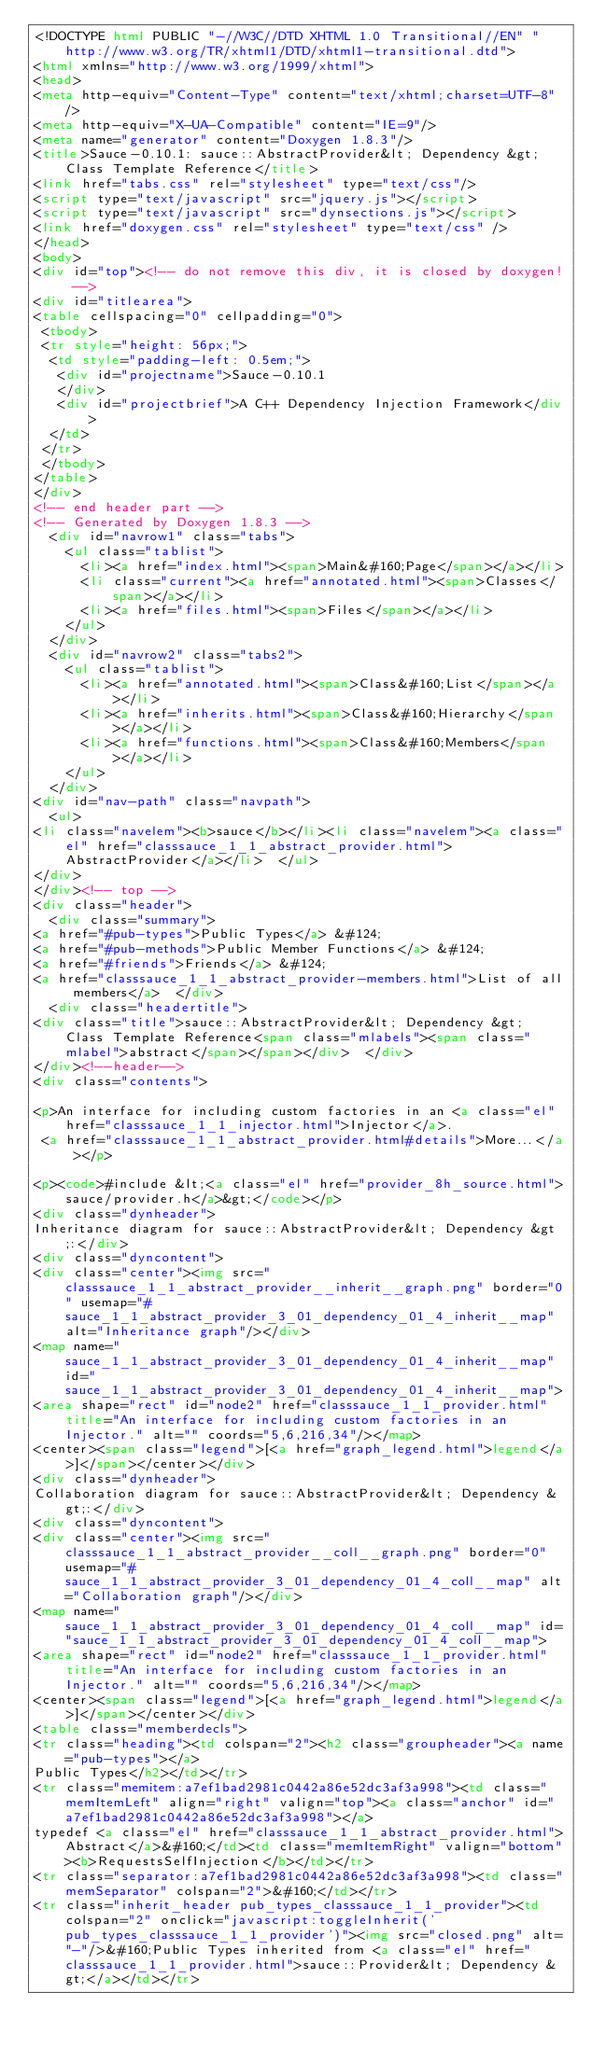Convert code to text. <code><loc_0><loc_0><loc_500><loc_500><_HTML_><!DOCTYPE html PUBLIC "-//W3C//DTD XHTML 1.0 Transitional//EN" "http://www.w3.org/TR/xhtml1/DTD/xhtml1-transitional.dtd">
<html xmlns="http://www.w3.org/1999/xhtml">
<head>
<meta http-equiv="Content-Type" content="text/xhtml;charset=UTF-8"/>
<meta http-equiv="X-UA-Compatible" content="IE=9"/>
<meta name="generator" content="Doxygen 1.8.3"/>
<title>Sauce-0.10.1: sauce::AbstractProvider&lt; Dependency &gt; Class Template Reference</title>
<link href="tabs.css" rel="stylesheet" type="text/css"/>
<script type="text/javascript" src="jquery.js"></script>
<script type="text/javascript" src="dynsections.js"></script>
<link href="doxygen.css" rel="stylesheet" type="text/css" />
</head>
<body>
<div id="top"><!-- do not remove this div, it is closed by doxygen! -->
<div id="titlearea">
<table cellspacing="0" cellpadding="0">
 <tbody>
 <tr style="height: 56px;">
  <td style="padding-left: 0.5em;">
   <div id="projectname">Sauce-0.10.1
   </div>
   <div id="projectbrief">A C++ Dependency Injection Framework</div>
  </td>
 </tr>
 </tbody>
</table>
</div>
<!-- end header part -->
<!-- Generated by Doxygen 1.8.3 -->
  <div id="navrow1" class="tabs">
    <ul class="tablist">
      <li><a href="index.html"><span>Main&#160;Page</span></a></li>
      <li class="current"><a href="annotated.html"><span>Classes</span></a></li>
      <li><a href="files.html"><span>Files</span></a></li>
    </ul>
  </div>
  <div id="navrow2" class="tabs2">
    <ul class="tablist">
      <li><a href="annotated.html"><span>Class&#160;List</span></a></li>
      <li><a href="inherits.html"><span>Class&#160;Hierarchy</span></a></li>
      <li><a href="functions.html"><span>Class&#160;Members</span></a></li>
    </ul>
  </div>
<div id="nav-path" class="navpath">
  <ul>
<li class="navelem"><b>sauce</b></li><li class="navelem"><a class="el" href="classsauce_1_1_abstract_provider.html">AbstractProvider</a></li>  </ul>
</div>
</div><!-- top -->
<div class="header">
  <div class="summary">
<a href="#pub-types">Public Types</a> &#124;
<a href="#pub-methods">Public Member Functions</a> &#124;
<a href="#friends">Friends</a> &#124;
<a href="classsauce_1_1_abstract_provider-members.html">List of all members</a>  </div>
  <div class="headertitle">
<div class="title">sauce::AbstractProvider&lt; Dependency &gt; Class Template Reference<span class="mlabels"><span class="mlabel">abstract</span></span></div>  </div>
</div><!--header-->
<div class="contents">

<p>An interface for including custom factories in an <a class="el" href="classsauce_1_1_injector.html">Injector</a>.  
 <a href="classsauce_1_1_abstract_provider.html#details">More...</a></p>

<p><code>#include &lt;<a class="el" href="provider_8h_source.html">sauce/provider.h</a>&gt;</code></p>
<div class="dynheader">
Inheritance diagram for sauce::AbstractProvider&lt; Dependency &gt;:</div>
<div class="dyncontent">
<div class="center"><img src="classsauce_1_1_abstract_provider__inherit__graph.png" border="0" usemap="#sauce_1_1_abstract_provider_3_01_dependency_01_4_inherit__map" alt="Inheritance graph"/></div>
<map name="sauce_1_1_abstract_provider_3_01_dependency_01_4_inherit__map" id="sauce_1_1_abstract_provider_3_01_dependency_01_4_inherit__map">
<area shape="rect" id="node2" href="classsauce_1_1_provider.html" title="An interface for including custom factories in an Injector." alt="" coords="5,6,216,34"/></map>
<center><span class="legend">[<a href="graph_legend.html">legend</a>]</span></center></div>
<div class="dynheader">
Collaboration diagram for sauce::AbstractProvider&lt; Dependency &gt;:</div>
<div class="dyncontent">
<div class="center"><img src="classsauce_1_1_abstract_provider__coll__graph.png" border="0" usemap="#sauce_1_1_abstract_provider_3_01_dependency_01_4_coll__map" alt="Collaboration graph"/></div>
<map name="sauce_1_1_abstract_provider_3_01_dependency_01_4_coll__map" id="sauce_1_1_abstract_provider_3_01_dependency_01_4_coll__map">
<area shape="rect" id="node2" href="classsauce_1_1_provider.html" title="An interface for including custom factories in an Injector." alt="" coords="5,6,216,34"/></map>
<center><span class="legend">[<a href="graph_legend.html">legend</a>]</span></center></div>
<table class="memberdecls">
<tr class="heading"><td colspan="2"><h2 class="groupheader"><a name="pub-types"></a>
Public Types</h2></td></tr>
<tr class="memitem:a7ef1bad2981c0442a86e52dc3af3a998"><td class="memItemLeft" align="right" valign="top"><a class="anchor" id="a7ef1bad2981c0442a86e52dc3af3a998"></a>
typedef <a class="el" href="classsauce_1_1_abstract_provider.html">Abstract</a>&#160;</td><td class="memItemRight" valign="bottom"><b>RequestsSelfInjection</b></td></tr>
<tr class="separator:a7ef1bad2981c0442a86e52dc3af3a998"><td class="memSeparator" colspan="2">&#160;</td></tr>
<tr class="inherit_header pub_types_classsauce_1_1_provider"><td colspan="2" onclick="javascript:toggleInherit('pub_types_classsauce_1_1_provider')"><img src="closed.png" alt="-"/>&#160;Public Types inherited from <a class="el" href="classsauce_1_1_provider.html">sauce::Provider&lt; Dependency &gt;</a></td></tr></code> 